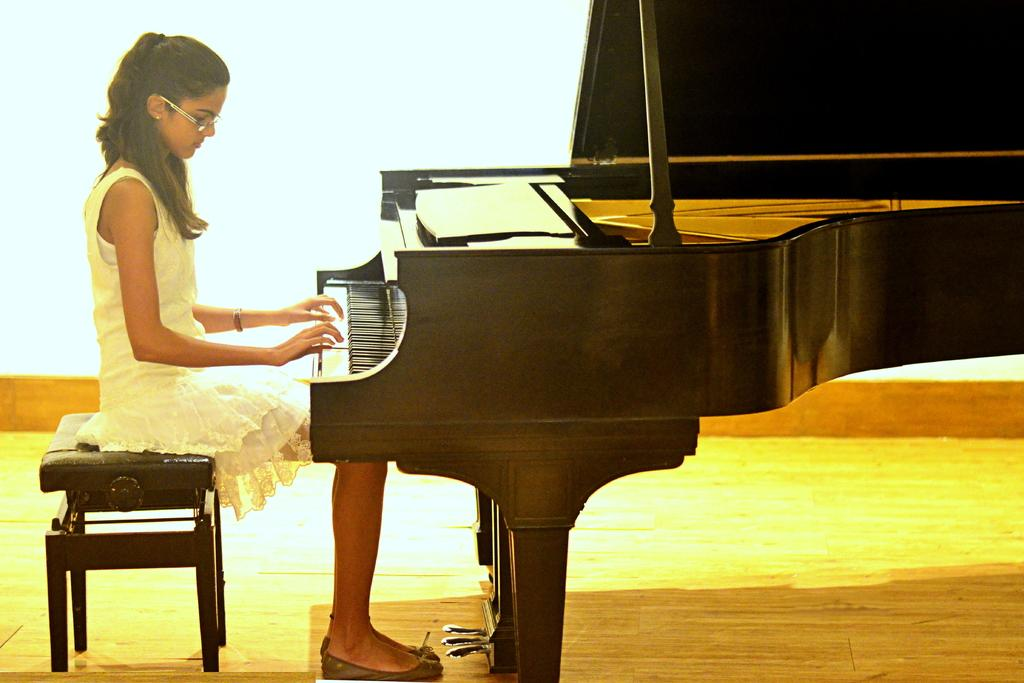What is the main subject of the image? There is a person in the image. What is the person doing in the image? The person is playing a keyboard. What is the person sitting on while playing the keyboard? The person is sitting on a stool. What type of division is the person performing on the keyboard in the image? There is no indication in the image that the person is performing any specific type of division on the keyboard. What type of toy is the person playing with in the image? The image does not depict a toy; it shows a person playing a keyboard. What type of laborer is the person in the image? The image does not depict a laborer; it shows a person playing a keyboard. 